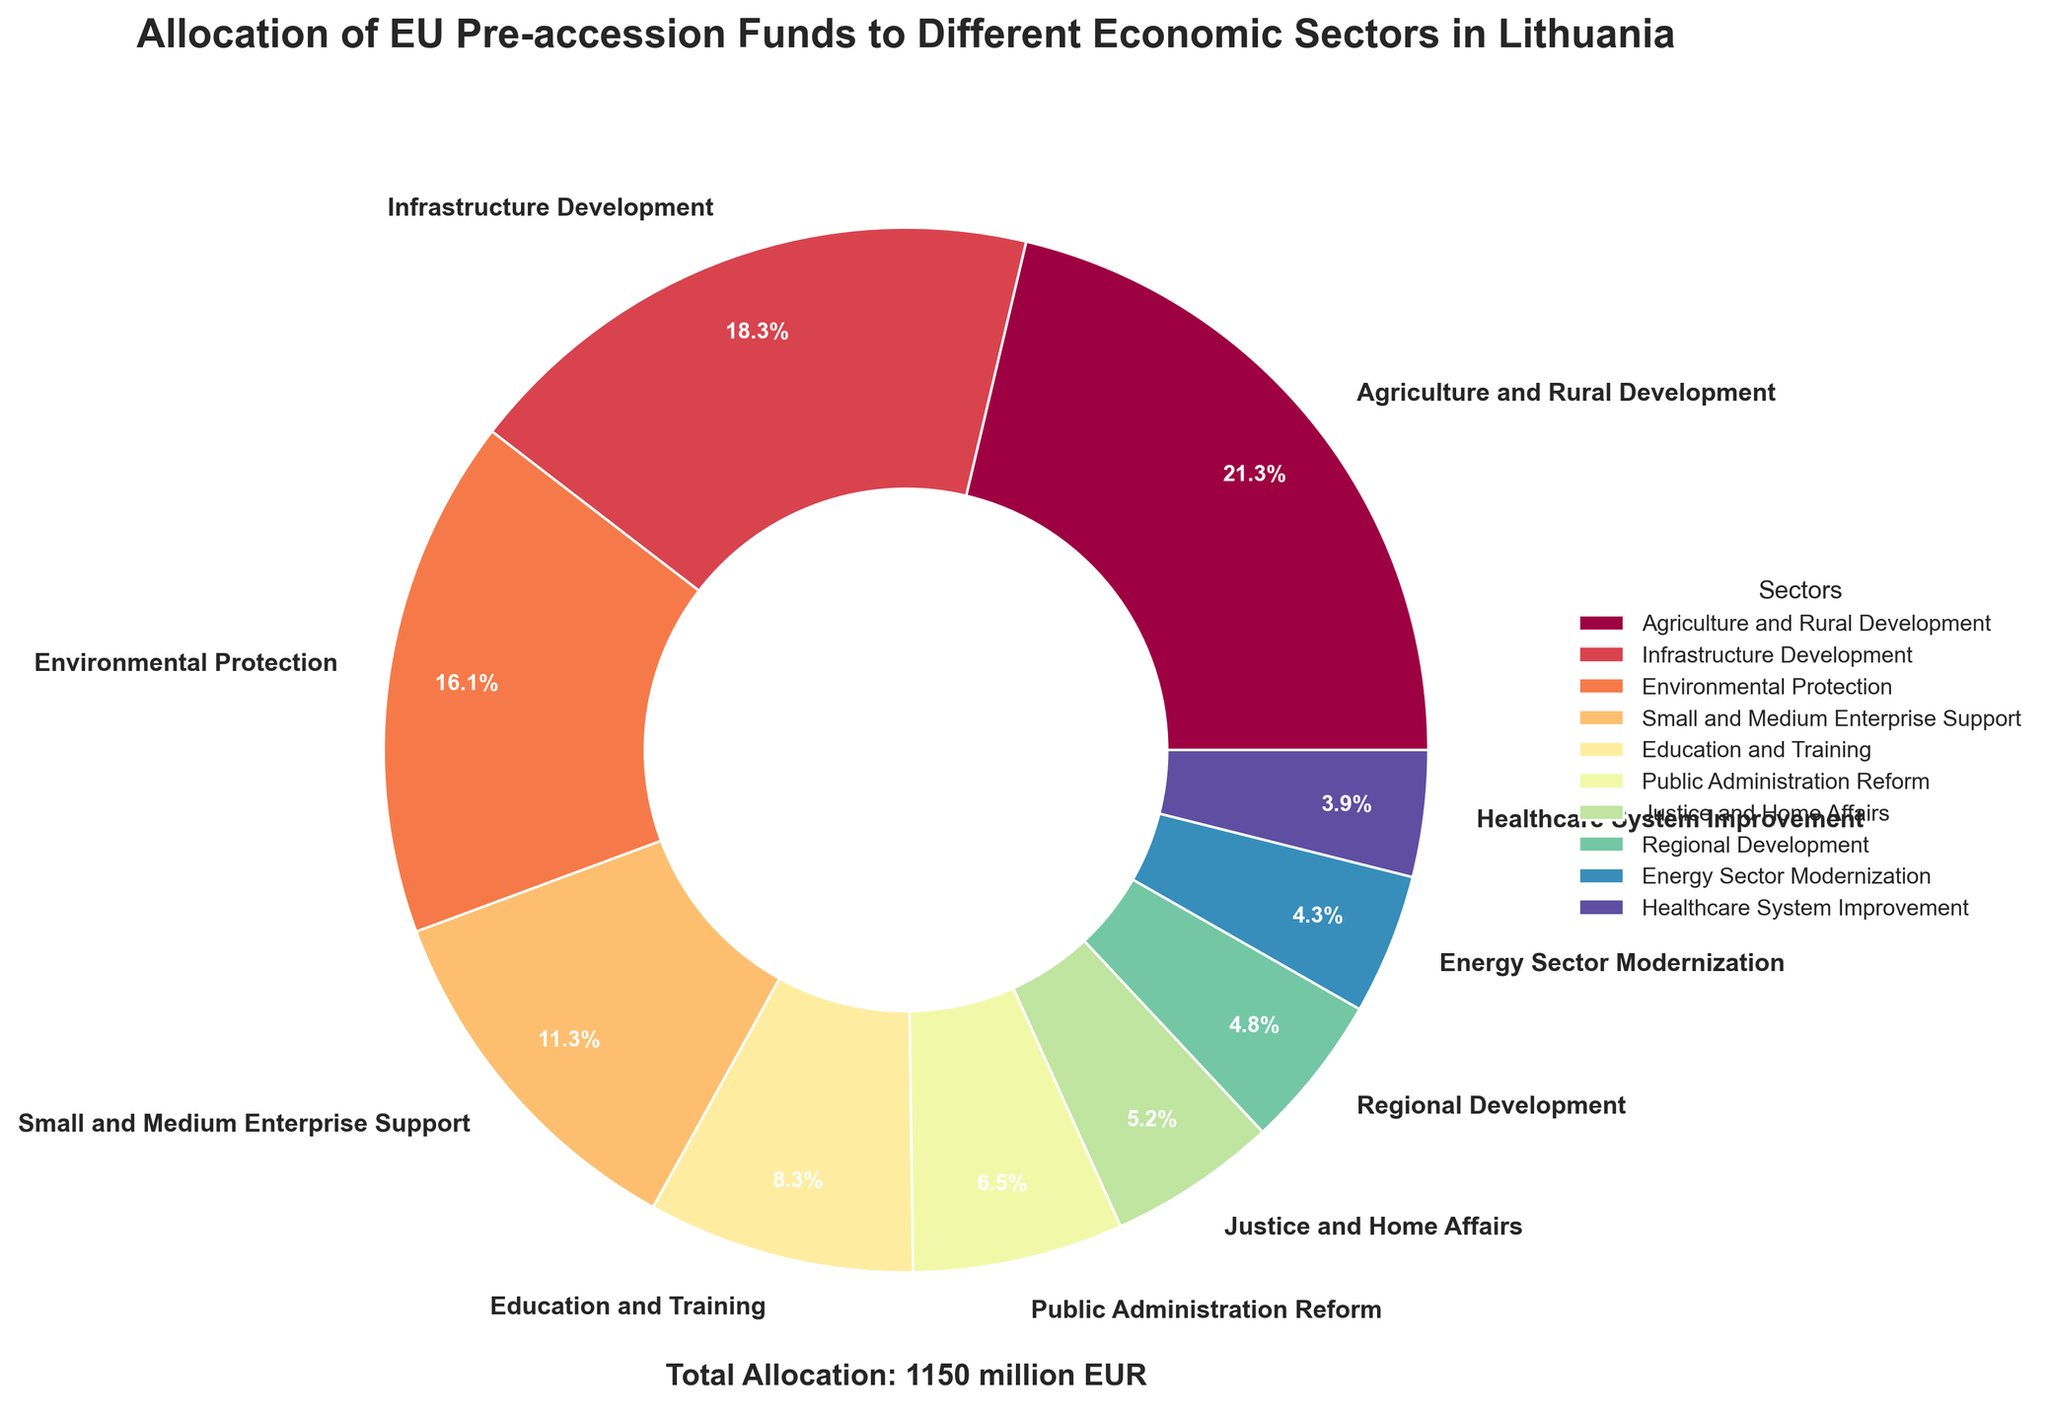What's the sector with the highest allocation? The pie chart shows the relative proportions of EU pre-accession funds allocated to different sectors. The sector labeled as "Agriculture and Rural Development" visually has the largest segment, indicating it's the highest.
Answer: Agriculture and Rural Development What percentage of total funds is allocated to Infrastructure Development? The pie chart labels show the percentage of total funds allocated to each sector. The segment for Infrastructure Development is labeled as 17.1%.
Answer: 17.1% Which sector has the smallest allocation, and what is its percentage? By observing the pie chart, we can see that the smallest slice belongs to Healthcare System Improvement. Its percentage is labeled as 3.7%.
Answer: Healthcare System Improvement, 3.7% What is the combined allocation percentage for Public Administration Reform and Justice and Home Affairs? We need to locate the segments for Public Administration Reform and Justice and Home Affairs on the pie chart and sum their percentages. Public Administration Reform is 6.1%, and Justice and Home Affairs is 4.9%, giving a total of 6.1% + 4.9% = 11.0%.
Answer: 11.0% Which sector receives more funding: Education and Training or Small and Medium Enterprise Support? The pie chart visually compares the sizes of allocations. Education and Training is allocated 95 million EUR, and Small and Medium Enterprise Support is allocated 130 million EUR. Small and Medium Enterprise Support has the larger segment.
Answer: Small and Medium Enterprise Support How much more is allocated to Environmental Protection than to Energy Sector Modernization? The difference in allocation between Environmental Protection and Energy Sector Modernization is calculated as 185 million EUR for Environmental Protection minus 50 million EUR for Energy Sector Modernization, which equals 135 million EUR.
Answer: 135 million EUR What is the total percentage allocation for Agriculture and Rural Development, Infrastructure Development, and Environmental Protection combined? We sum the percentages for Agriculture and Rural Development (20.0%), Infrastructure Development (17.1%), and Environmental Protection (15.1%). So, 20.0% + 17.1% + 15.1% = 52.2%.
Answer: 52.2% What is the difference in percentage allocation between the highest and lowest funded sectors? The highest allocated sector is Agriculture and Rural Development at 20.0%, and the lowest is Healthcare System Improvement at 3.7%. The difference is 20.0% - 3.7% = 16.3%.
Answer: 16.3% How many sectors have an allocation percentage greater than 10%? We count the sectors with percentage values greater than 10%: Agriculture and Rural Development (20.0%), Infrastructure Development (17.1%), Environmental Protection (15.1%), and Small and Medium Enterprise Support (10.6%). There are 4 such sectors.
Answer: 4 What is the allocation percentage for the sectors other than Agriculture and Rural Development and Infrastructure Development? First, sum the percentages of Agriculture and Rural Development (20.0%) and Infrastructure Development (17.1%), which is 37.1%. Then subtract this from 100% to find the percentage of all other sectors: 100% - 37.1% = 62.9%.
Answer: 62.9% 